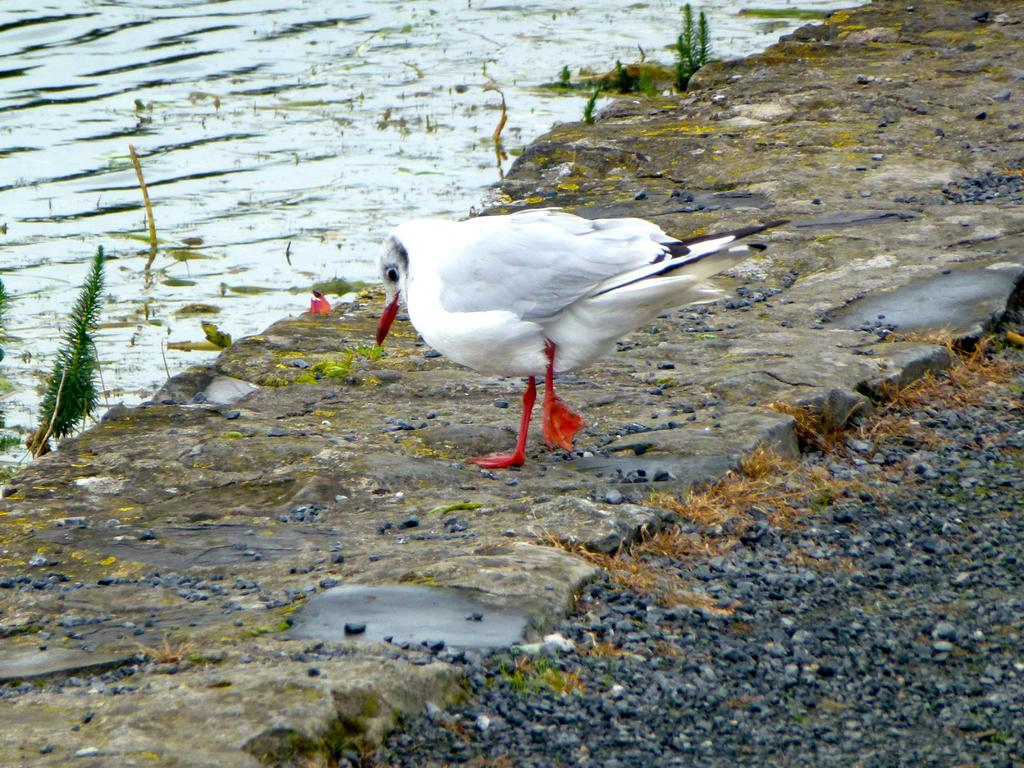What type of animal is on the surface in the image? There is a white color bird on the surface in the image. What can be seen on the right side of the image? There are stones on the right side of the image. What is on the left side of the image? There is water on the left side of the image. What type of vegetation is present in the image? There are small plants in the image. What is the surface made of? There is grass on the surface in the image. Can you see any mountains in the image? There are no mountains visible in the image. Are there any boats in the water on the left side of the image? There are no boats present in the image. 